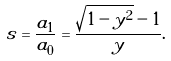<formula> <loc_0><loc_0><loc_500><loc_500>s = \frac { a _ { 1 } } { a _ { 0 } } = \frac { \sqrt { 1 - y ^ { 2 } } - 1 } { y } .</formula> 